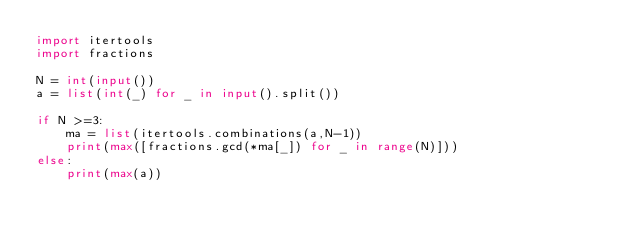Convert code to text. <code><loc_0><loc_0><loc_500><loc_500><_Python_>import itertools
import fractions

N = int(input()) 
a = list(int(_) for _ in input().split()) 

if N >=3:
    ma = list(itertools.combinations(a,N-1))
    print(max([fractions.gcd(*ma[_]) for _ in range(N)]))
else:
    print(max(a))</code> 